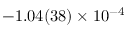<formula> <loc_0><loc_0><loc_500><loc_500>- 1 . 0 4 ( 3 8 ) \times 1 0 ^ { - 4 }</formula> 